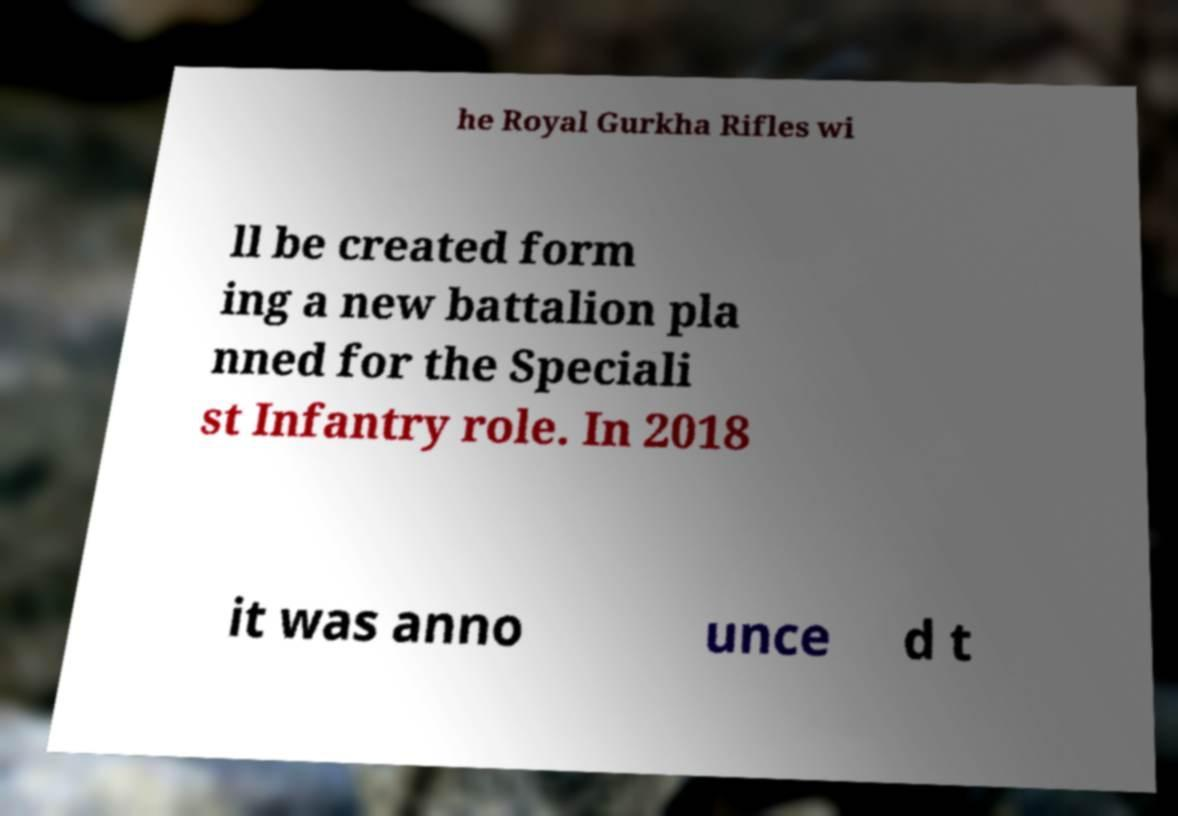There's text embedded in this image that I need extracted. Can you transcribe it verbatim? he Royal Gurkha Rifles wi ll be created form ing a new battalion pla nned for the Speciali st Infantry role. In 2018 it was anno unce d t 